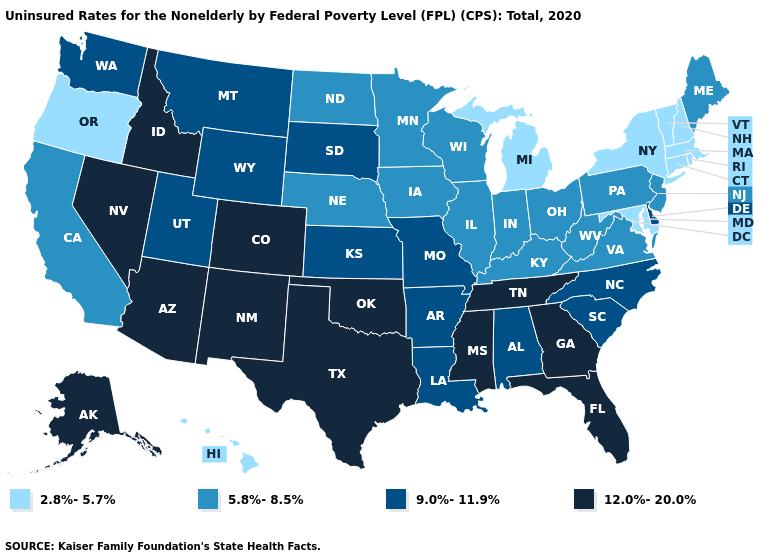Does Rhode Island have the lowest value in the USA?
Quick response, please. Yes. What is the value of Arizona?
Answer briefly. 12.0%-20.0%. Name the states that have a value in the range 12.0%-20.0%?
Keep it brief. Alaska, Arizona, Colorado, Florida, Georgia, Idaho, Mississippi, Nevada, New Mexico, Oklahoma, Tennessee, Texas. Does Washington have the highest value in the USA?
Write a very short answer. No. Which states have the lowest value in the USA?
Quick response, please. Connecticut, Hawaii, Maryland, Massachusetts, Michigan, New Hampshire, New York, Oregon, Rhode Island, Vermont. Name the states that have a value in the range 2.8%-5.7%?
Short answer required. Connecticut, Hawaii, Maryland, Massachusetts, Michigan, New Hampshire, New York, Oregon, Rhode Island, Vermont. How many symbols are there in the legend?
Give a very brief answer. 4. What is the value of Illinois?
Short answer required. 5.8%-8.5%. Does Arizona have the lowest value in the USA?
Answer briefly. No. Which states have the lowest value in the South?
Answer briefly. Maryland. What is the lowest value in the USA?
Answer briefly. 2.8%-5.7%. What is the value of New York?
Concise answer only. 2.8%-5.7%. Name the states that have a value in the range 9.0%-11.9%?
Write a very short answer. Alabama, Arkansas, Delaware, Kansas, Louisiana, Missouri, Montana, North Carolina, South Carolina, South Dakota, Utah, Washington, Wyoming. Name the states that have a value in the range 5.8%-8.5%?
Write a very short answer. California, Illinois, Indiana, Iowa, Kentucky, Maine, Minnesota, Nebraska, New Jersey, North Dakota, Ohio, Pennsylvania, Virginia, West Virginia, Wisconsin. 